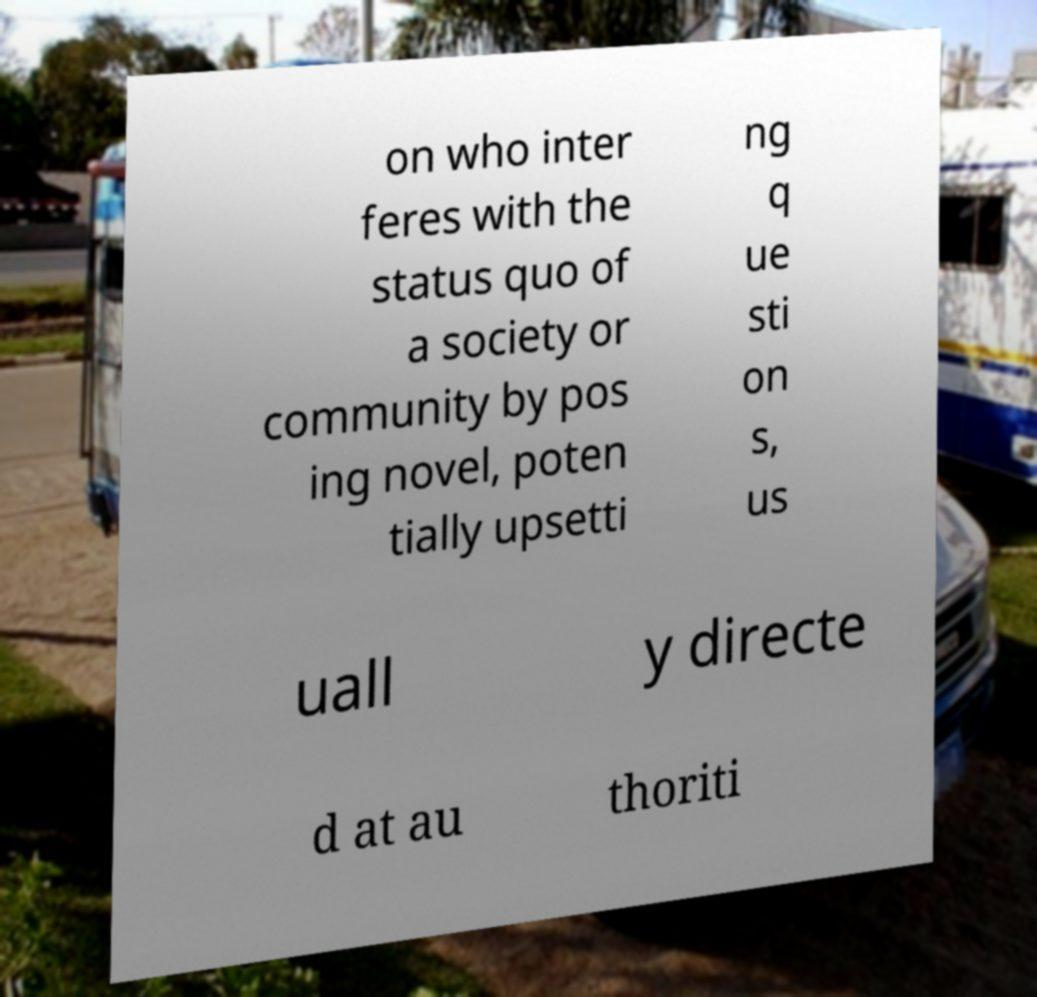Please identify and transcribe the text found in this image. on who inter feres with the status quo of a society or community by pos ing novel, poten tially upsetti ng q ue sti on s, us uall y directe d at au thoriti 